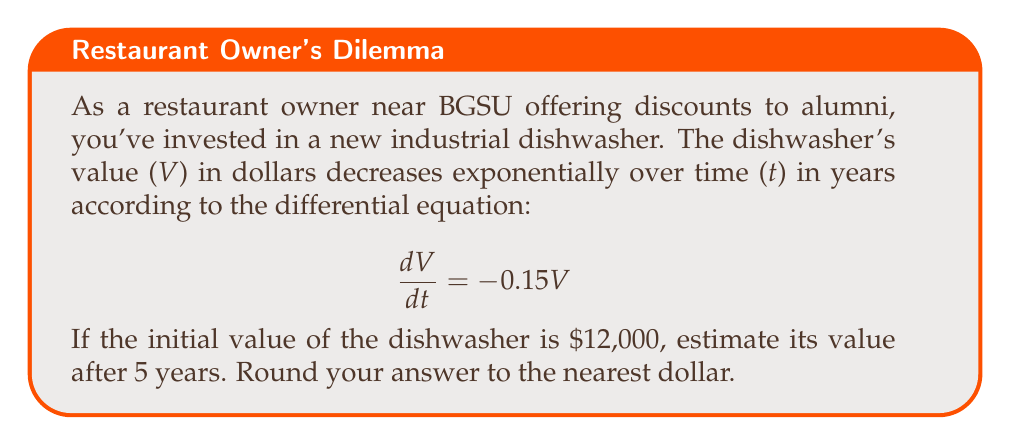Teach me how to tackle this problem. To solve this problem, we need to use the first-order linear differential equation for exponential decay:

1) The general form of the equation is:
   $$\frac{dV}{dt} = kV$$
   where k is the decay constant. In this case, $k = -0.15$.

2) The solution to this differential equation is:
   $$V(t) = V_0 e^{kt}$$
   where $V_0$ is the initial value.

3) We're given:
   $V_0 = 12,000$ (initial value)
   $k = -0.15$ (decay constant)
   $t = 5$ (time in years)

4) Substituting these values into our solution:
   $$V(5) = 12,000 \cdot e^{-0.15 \cdot 5}$$

5) Simplifying:
   $$V(5) = 12,000 \cdot e^{-0.75}$$

6) Using a calculator or computer to evaluate:
   $$V(5) \approx 12,000 \cdot 0.4724 \approx 5,668.80$$

7) Rounding to the nearest dollar:
   $$V(5) \approx 5,669$$

Therefore, after 5 years, the estimated value of the dishwasher will be $5,669.
Answer: $5,669 